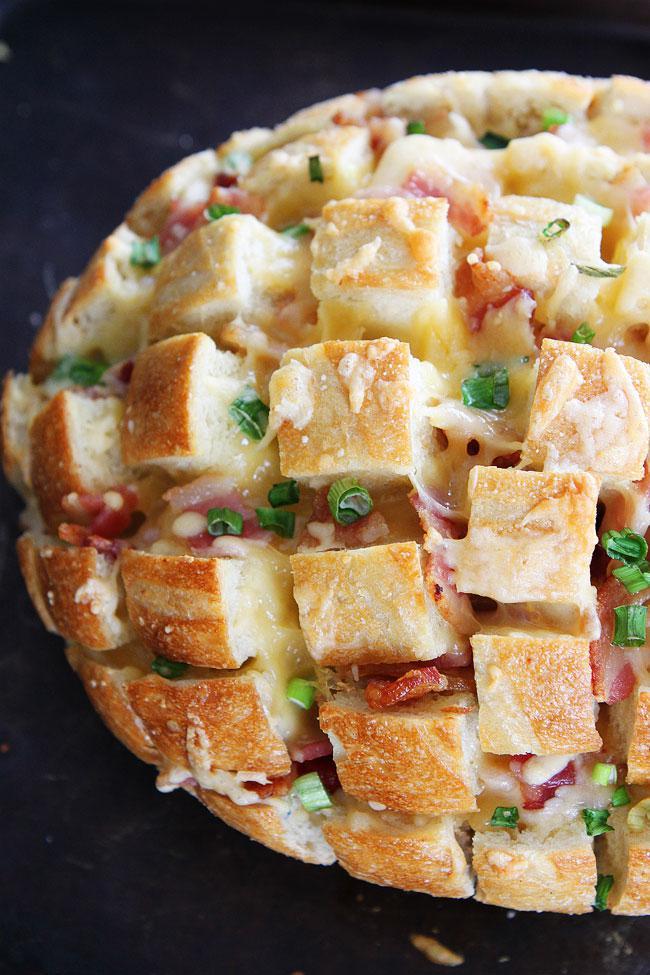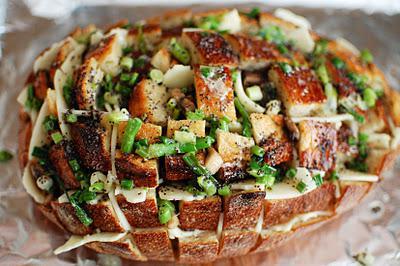The first image is the image on the left, the second image is the image on the right. Evaluate the accuracy of this statement regarding the images: "Both of the pizza breads contain pepperoni.". Is it true? Answer yes or no. No. 